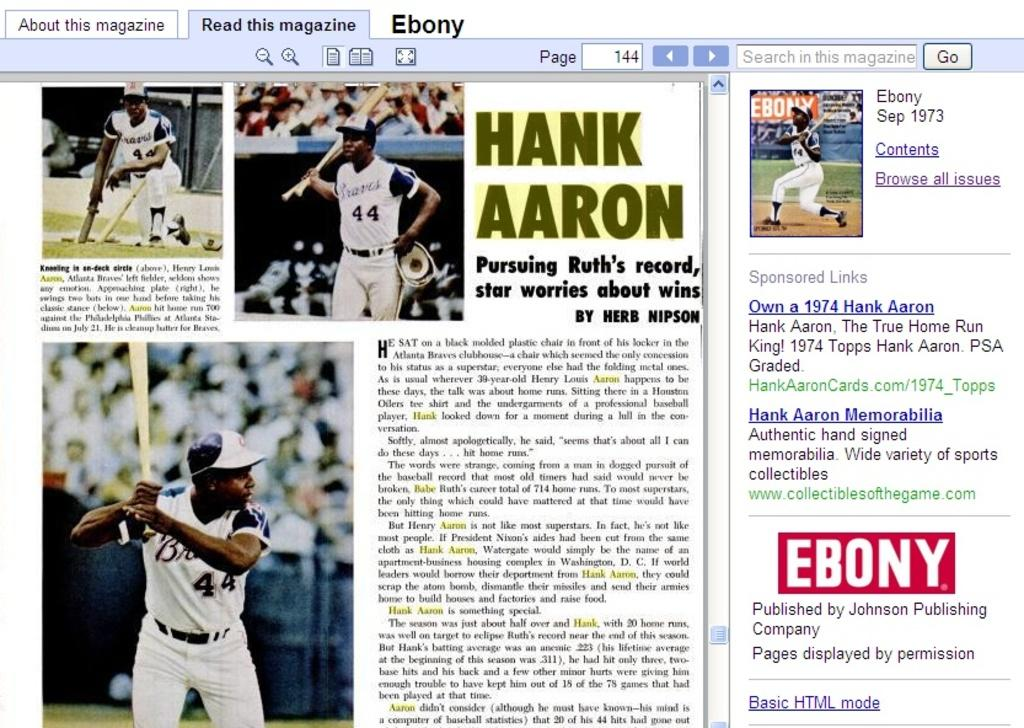<image>
Summarize the visual content of the image. A computer is open to an article in Ebony about Hank Aaron. 